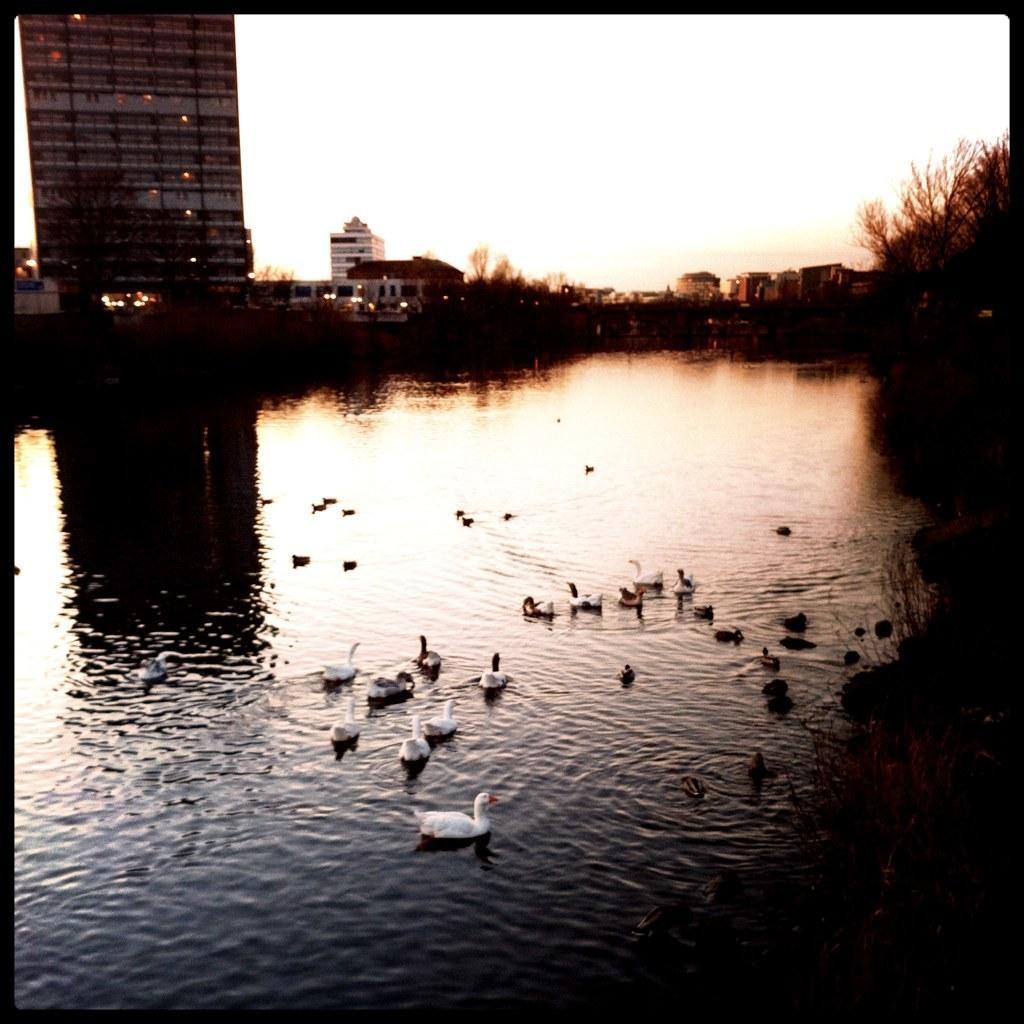Please provide a concise description of this image. In this picture we can see a group of birds on the water, trees, buildings, lights and in the background we can see the sky. 